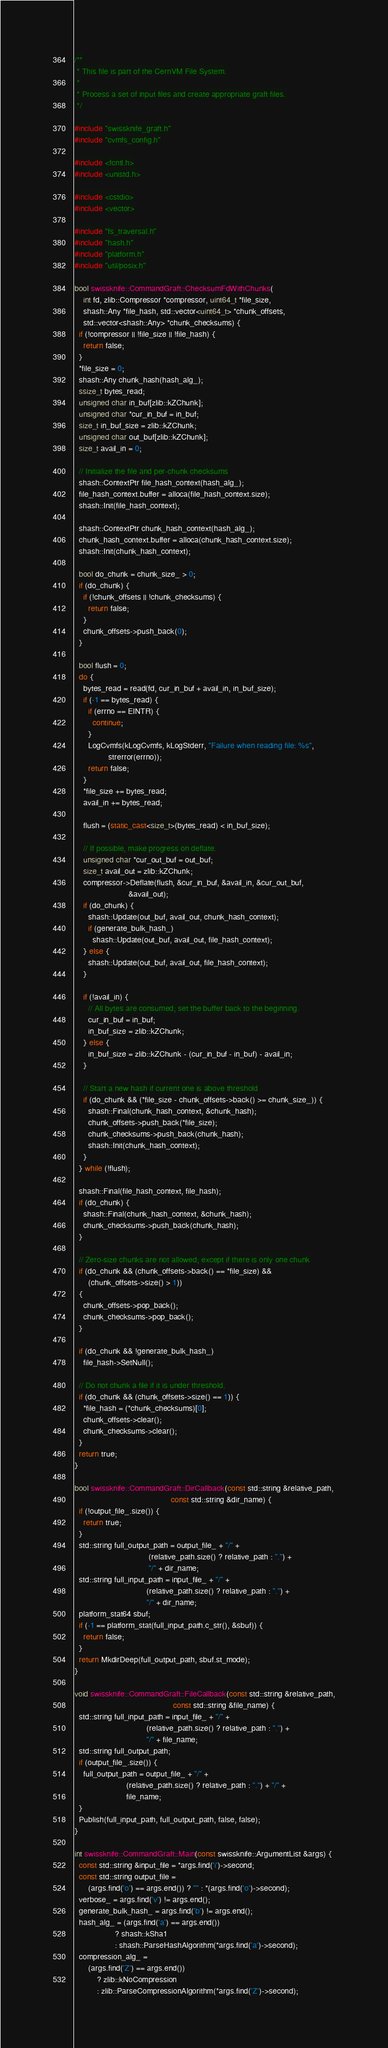<code> <loc_0><loc_0><loc_500><loc_500><_C++_>/**
 * This file is part of the CernVM File System.
 *
 * Process a set of input files and create appropriate graft files.
 */

#include "swissknife_graft.h"
#include "cvmfs_config.h"

#include <fcntl.h>
#include <unistd.h>

#include <cstdio>
#include <vector>

#include "fs_traversal.h"
#include "hash.h"
#include "platform.h"
#include "util/posix.h"

bool swissknife::CommandGraft::ChecksumFdWithChunks(
    int fd, zlib::Compressor *compressor, uint64_t *file_size,
    shash::Any *file_hash, std::vector<uint64_t> *chunk_offsets,
    std::vector<shash::Any> *chunk_checksums) {
  if (!compressor || !file_size || !file_hash) {
    return false;
  }
  *file_size = 0;
  shash::Any chunk_hash(hash_alg_);
  ssize_t bytes_read;
  unsigned char in_buf[zlib::kZChunk];
  unsigned char *cur_in_buf = in_buf;
  size_t in_buf_size = zlib::kZChunk;
  unsigned char out_buf[zlib::kZChunk];
  size_t avail_in = 0;

  // Initialize the file and per-chunk checksums
  shash::ContextPtr file_hash_context(hash_alg_);
  file_hash_context.buffer = alloca(file_hash_context.size);
  shash::Init(file_hash_context);

  shash::ContextPtr chunk_hash_context(hash_alg_);
  chunk_hash_context.buffer = alloca(chunk_hash_context.size);
  shash::Init(chunk_hash_context);

  bool do_chunk = chunk_size_ > 0;
  if (do_chunk) {
    if (!chunk_offsets || !chunk_checksums) {
      return false;
    }
    chunk_offsets->push_back(0);
  }

  bool flush = 0;
  do {
    bytes_read = read(fd, cur_in_buf + avail_in, in_buf_size);
    if (-1 == bytes_read) {
      if (errno == EINTR) {
        continue;
      }
      LogCvmfs(kLogCvmfs, kLogStderr, "Failure when reading file: %s",
               strerror(errno));
      return false;
    }
    *file_size += bytes_read;
    avail_in += bytes_read;

    flush = (static_cast<size_t>(bytes_read) < in_buf_size);

    // If possible, make progress on deflate.
    unsigned char *cur_out_buf = out_buf;
    size_t avail_out = zlib::kZChunk;
    compressor->Deflate(flush, &cur_in_buf, &avail_in, &cur_out_buf,
                        &avail_out);
    if (do_chunk) {
      shash::Update(out_buf, avail_out, chunk_hash_context);
      if (generate_bulk_hash_)
        shash::Update(out_buf, avail_out, file_hash_context);
    } else {
      shash::Update(out_buf, avail_out, file_hash_context);
    }

    if (!avail_in) {
      // All bytes are consumed; set the buffer back to the beginning.
      cur_in_buf = in_buf;
      in_buf_size = zlib::kZChunk;
    } else {
      in_buf_size = zlib::kZChunk - (cur_in_buf - in_buf) - avail_in;
    }

    // Start a new hash if current one is above threshold
    if (do_chunk && (*file_size - chunk_offsets->back() >= chunk_size_)) {
      shash::Final(chunk_hash_context, &chunk_hash);
      chunk_offsets->push_back(*file_size);
      chunk_checksums->push_back(chunk_hash);
      shash::Init(chunk_hash_context);
    }
  } while (!flush);

  shash::Final(file_hash_context, file_hash);
  if (do_chunk) {
    shash::Final(chunk_hash_context, &chunk_hash);
    chunk_checksums->push_back(chunk_hash);
  }

  // Zero-size chunks are not allowed; except if there is only one chunk
  if (do_chunk && (chunk_offsets->back() == *file_size) &&
      (chunk_offsets->size() > 1))
  {
    chunk_offsets->pop_back();
    chunk_checksums->pop_back();
  }

  if (do_chunk && !generate_bulk_hash_)
    file_hash->SetNull();

  // Do not chunk a file if it is under threshold.
  if (do_chunk && (chunk_offsets->size() == 1)) {
    *file_hash = (*chunk_checksums)[0];
    chunk_offsets->clear();
    chunk_checksums->clear();
  }
  return true;
}

bool swissknife::CommandGraft::DirCallback(const std::string &relative_path,
                                           const std::string &dir_name) {
  if (!output_file_.size()) {
    return true;
  }
  std::string full_output_path = output_file_ + "/" +
                                 (relative_path.size() ? relative_path : ".") +
                                 "/" + dir_name;
  std::string full_input_path = input_file_ + "/" +
                                (relative_path.size() ? relative_path : ".") +
                                "/" + dir_name;
  platform_stat64 sbuf;
  if (-1 == platform_stat(full_input_path.c_str(), &sbuf)) {
    return false;
  }
  return MkdirDeep(full_output_path, sbuf.st_mode);
}

void swissknife::CommandGraft::FileCallback(const std::string &relative_path,
                                            const std::string &file_name) {
  std::string full_input_path = input_file_ + "/" +
                                (relative_path.size() ? relative_path : ".") +
                                "/" + file_name;
  std::string full_output_path;
  if (output_file_.size()) {
    full_output_path = output_file_ + "/" +
                       (relative_path.size() ? relative_path : ".") + "/" +
                       file_name;
  }
  Publish(full_input_path, full_output_path, false, false);
}

int swissknife::CommandGraft::Main(const swissknife::ArgumentList &args) {
  const std::string &input_file = *args.find('i')->second;
  const std::string output_file =
      (args.find('o') == args.end()) ? "" : *(args.find('o')->second);
  verbose_ = args.find('v') != args.end();
  generate_bulk_hash_ = args.find('b') != args.end();
  hash_alg_ = (args.find('a') == args.end())
                  ? shash::kSha1
                  : shash::ParseHashAlgorithm(*args.find('a')->second);
  compression_alg_ =
      (args.find('Z') == args.end())
          ? zlib::kNoCompression
          : zlib::ParseCompressionAlgorithm(*args.find('Z')->second);
</code> 